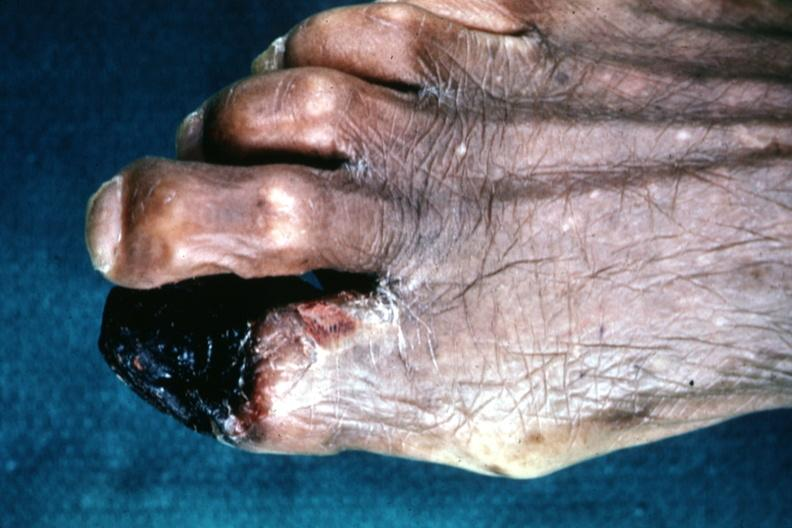re extremities present?
Answer the question using a single word or phrase. Yes 